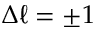<formula> <loc_0><loc_0><loc_500><loc_500>\Delta \ell = \pm 1</formula> 